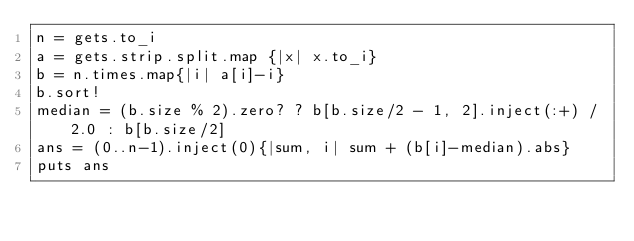<code> <loc_0><loc_0><loc_500><loc_500><_Ruby_>n = gets.to_i
a = gets.strip.split.map {|x| x.to_i}
b = n.times.map{|i| a[i]-i}
b.sort!
median = (b.size % 2).zero? ? b[b.size/2 - 1, 2].inject(:+) / 2.0 : b[b.size/2]
ans = (0..n-1).inject(0){|sum, i| sum + (b[i]-median).abs}
puts ans

</code> 